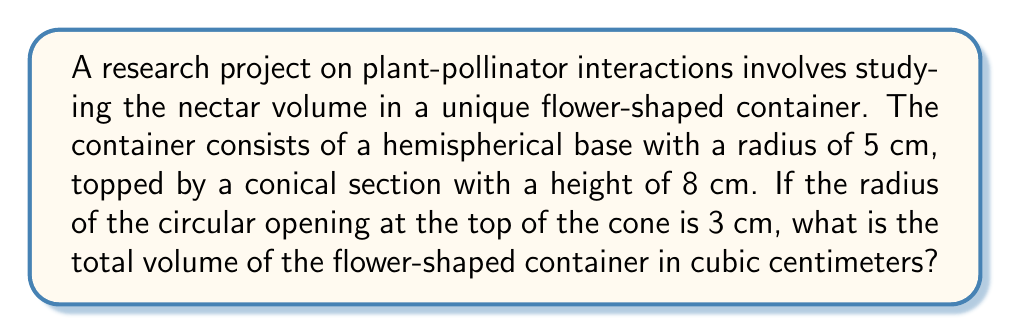Give your solution to this math problem. To solve this problem, we need to calculate the volumes of both the hemispherical base and the conical top, then add them together.

1. Volume of the hemispherical base:
   The formula for the volume of a hemisphere is:
   $$V_{hemisphere} = \frac{2}{3}\pi r^3$$
   Where $r$ is the radius of the hemisphere.
   $$V_{hemisphere} = \frac{2}{3}\pi (5\text{ cm})^3 = \frac{250}{3}\pi \text{ cm}^3$$

2. Volume of the conical top:
   The formula for the volume of a cone is:
   $$V_{cone} = \frac{1}{3}\pi r^2 h$$
   Where $r$ is the radius of the base and $h$ is the height.
   
   However, we need to find the radius of the base of the cone, which is the same as the radius of the hemisphere (5 cm).
   
   Using similar triangles, we can set up the following proportion:
   $$\frac{5-3}{8} = \frac{5}{x}$$
   Where $x$ is the total height of the cone if it were complete.
   
   Solving for $x$:
   $$x = \frac{40}{2} = 20\text{ cm}$$
   
   Now we can calculate the volume of the cone:
   $$V_{cone} = \frac{1}{3}\pi (5\text{ cm})^2 (8\text{ cm}) = \frac{200}{3}\pi \text{ cm}^3$$

3. Total volume:
   $$V_{total} = V_{hemisphere} + V_{cone} = \frac{250}{3}\pi \text{ cm}^3 + \frac{200}{3}\pi \text{ cm}^3 = \frac{450}{3}\pi \text{ cm}^3 = 150\pi \text{ cm}^3$$
Answer: $150\pi \text{ cm}^3$ 